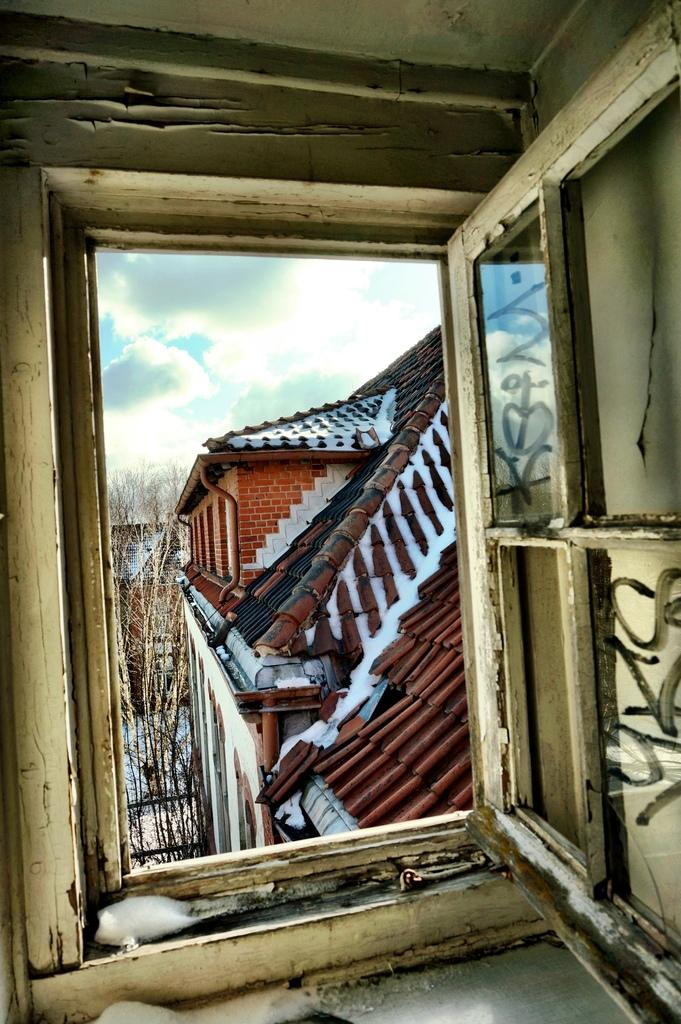What can be seen through the window in the image? Roof houses, trees, snow, and the sky are visible through the window in the image. What is the weather like outside based on the visible elements? The presence of snow suggests that it is cold outside, and the clouds visible in the sky indicate that it might be overcast. What is written or printed on the window glasses? There is text on the window glasses. Can you see a cemetery through the window in the image? There is no mention of a cemetery in the image, so it cannot be confirmed or denied. Is there a snake visible through the window in the image? There is no snake present in the image; the visible elements are roof houses, trees, snow, and the sky. 